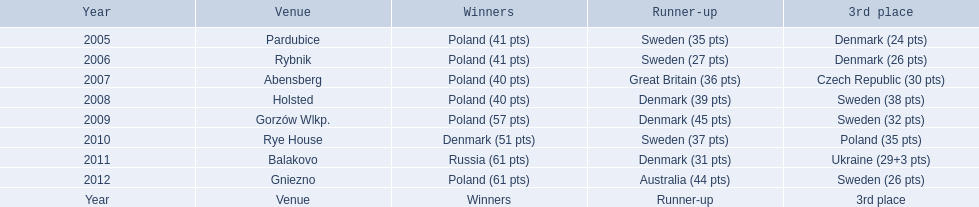In what years did denmark achieve a top 3 standing in the team speedway junior world championship? 2005, 2006, 2008, 2009, 2010, 2011. In which year was denmark within 2 points of a better ranking? 2006. What position did denmark attain in the year they were only 2 points away from a higher rank? 3rd place. 